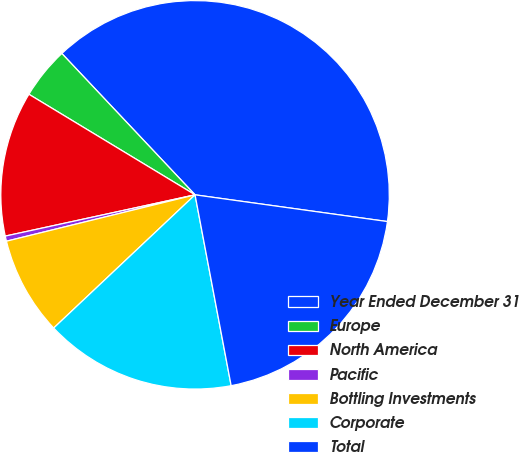<chart> <loc_0><loc_0><loc_500><loc_500><pie_chart><fcel>Year Ended December 31<fcel>Europe<fcel>North America<fcel>Pacific<fcel>Bottling Investments<fcel>Corporate<fcel>Total<nl><fcel>39.23%<fcel>4.31%<fcel>12.07%<fcel>0.43%<fcel>8.19%<fcel>15.95%<fcel>19.83%<nl></chart> 